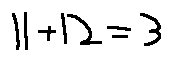<formula> <loc_0><loc_0><loc_500><loc_500>1 1 + 1 2 = 3</formula> 